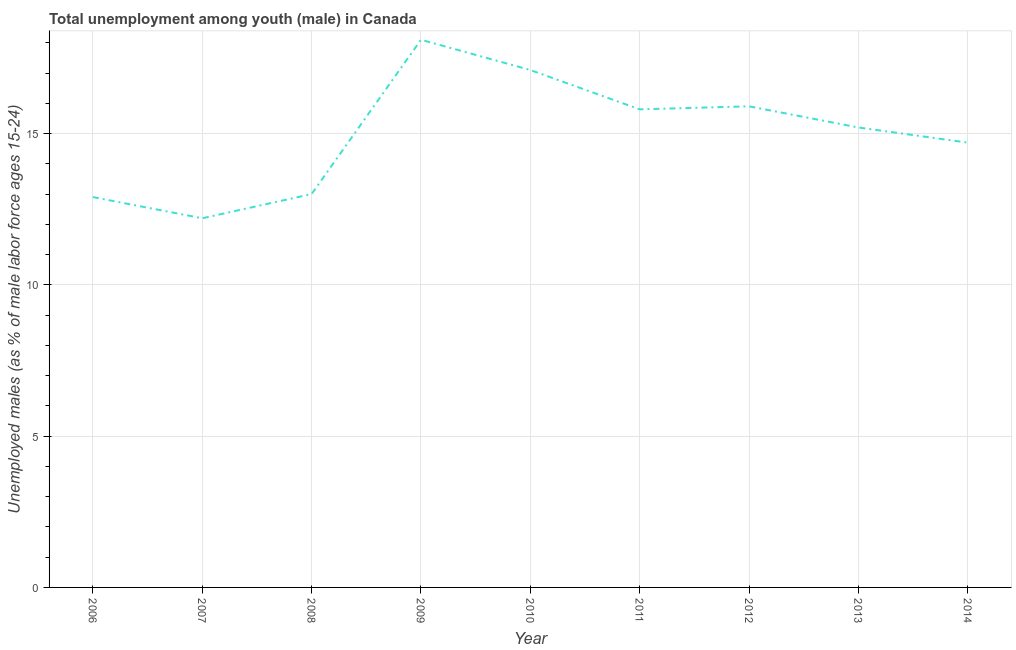What is the unemployed male youth population in 2009?
Keep it short and to the point. 18.1. Across all years, what is the maximum unemployed male youth population?
Provide a short and direct response. 18.1. Across all years, what is the minimum unemployed male youth population?
Give a very brief answer. 12.2. What is the sum of the unemployed male youth population?
Your answer should be compact. 134.9. What is the difference between the unemployed male youth population in 2010 and 2011?
Keep it short and to the point. 1.3. What is the average unemployed male youth population per year?
Your answer should be compact. 14.99. What is the median unemployed male youth population?
Give a very brief answer. 15.2. In how many years, is the unemployed male youth population greater than 12 %?
Offer a terse response. 9. What is the ratio of the unemployed male youth population in 2008 to that in 2010?
Give a very brief answer. 0.76. Is the unemployed male youth population in 2011 less than that in 2014?
Keep it short and to the point. No. Is the difference between the unemployed male youth population in 2011 and 2014 greater than the difference between any two years?
Offer a very short reply. No. What is the difference between the highest and the lowest unemployed male youth population?
Provide a succinct answer. 5.9. Does the unemployed male youth population monotonically increase over the years?
Provide a short and direct response. No. What is the difference between two consecutive major ticks on the Y-axis?
Provide a short and direct response. 5. What is the title of the graph?
Give a very brief answer. Total unemployment among youth (male) in Canada. What is the label or title of the Y-axis?
Make the answer very short. Unemployed males (as % of male labor force ages 15-24). What is the Unemployed males (as % of male labor force ages 15-24) in 2006?
Your response must be concise. 12.9. What is the Unemployed males (as % of male labor force ages 15-24) in 2007?
Your answer should be very brief. 12.2. What is the Unemployed males (as % of male labor force ages 15-24) of 2009?
Your answer should be compact. 18.1. What is the Unemployed males (as % of male labor force ages 15-24) of 2010?
Offer a very short reply. 17.1. What is the Unemployed males (as % of male labor force ages 15-24) in 2011?
Provide a succinct answer. 15.8. What is the Unemployed males (as % of male labor force ages 15-24) of 2012?
Offer a very short reply. 15.9. What is the Unemployed males (as % of male labor force ages 15-24) of 2013?
Your response must be concise. 15.2. What is the Unemployed males (as % of male labor force ages 15-24) of 2014?
Offer a terse response. 14.7. What is the difference between the Unemployed males (as % of male labor force ages 15-24) in 2006 and 2007?
Offer a very short reply. 0.7. What is the difference between the Unemployed males (as % of male labor force ages 15-24) in 2006 and 2009?
Offer a terse response. -5.2. What is the difference between the Unemployed males (as % of male labor force ages 15-24) in 2007 and 2010?
Give a very brief answer. -4.9. What is the difference between the Unemployed males (as % of male labor force ages 15-24) in 2007 and 2011?
Offer a terse response. -3.6. What is the difference between the Unemployed males (as % of male labor force ages 15-24) in 2007 and 2012?
Make the answer very short. -3.7. What is the difference between the Unemployed males (as % of male labor force ages 15-24) in 2008 and 2009?
Make the answer very short. -5.1. What is the difference between the Unemployed males (as % of male labor force ages 15-24) in 2008 and 2012?
Provide a succinct answer. -2.9. What is the difference between the Unemployed males (as % of male labor force ages 15-24) in 2008 and 2013?
Provide a succinct answer. -2.2. What is the difference between the Unemployed males (as % of male labor force ages 15-24) in 2009 and 2010?
Your answer should be compact. 1. What is the difference between the Unemployed males (as % of male labor force ages 15-24) in 2010 and 2014?
Your answer should be compact. 2.4. What is the difference between the Unemployed males (as % of male labor force ages 15-24) in 2011 and 2013?
Provide a short and direct response. 0.6. What is the difference between the Unemployed males (as % of male labor force ages 15-24) in 2012 and 2013?
Provide a succinct answer. 0.7. What is the ratio of the Unemployed males (as % of male labor force ages 15-24) in 2006 to that in 2007?
Offer a very short reply. 1.06. What is the ratio of the Unemployed males (as % of male labor force ages 15-24) in 2006 to that in 2008?
Ensure brevity in your answer.  0.99. What is the ratio of the Unemployed males (as % of male labor force ages 15-24) in 2006 to that in 2009?
Ensure brevity in your answer.  0.71. What is the ratio of the Unemployed males (as % of male labor force ages 15-24) in 2006 to that in 2010?
Keep it short and to the point. 0.75. What is the ratio of the Unemployed males (as % of male labor force ages 15-24) in 2006 to that in 2011?
Make the answer very short. 0.82. What is the ratio of the Unemployed males (as % of male labor force ages 15-24) in 2006 to that in 2012?
Offer a very short reply. 0.81. What is the ratio of the Unemployed males (as % of male labor force ages 15-24) in 2006 to that in 2013?
Give a very brief answer. 0.85. What is the ratio of the Unemployed males (as % of male labor force ages 15-24) in 2006 to that in 2014?
Your response must be concise. 0.88. What is the ratio of the Unemployed males (as % of male labor force ages 15-24) in 2007 to that in 2008?
Provide a short and direct response. 0.94. What is the ratio of the Unemployed males (as % of male labor force ages 15-24) in 2007 to that in 2009?
Your response must be concise. 0.67. What is the ratio of the Unemployed males (as % of male labor force ages 15-24) in 2007 to that in 2010?
Your response must be concise. 0.71. What is the ratio of the Unemployed males (as % of male labor force ages 15-24) in 2007 to that in 2011?
Give a very brief answer. 0.77. What is the ratio of the Unemployed males (as % of male labor force ages 15-24) in 2007 to that in 2012?
Ensure brevity in your answer.  0.77. What is the ratio of the Unemployed males (as % of male labor force ages 15-24) in 2007 to that in 2013?
Give a very brief answer. 0.8. What is the ratio of the Unemployed males (as % of male labor force ages 15-24) in 2007 to that in 2014?
Keep it short and to the point. 0.83. What is the ratio of the Unemployed males (as % of male labor force ages 15-24) in 2008 to that in 2009?
Offer a very short reply. 0.72. What is the ratio of the Unemployed males (as % of male labor force ages 15-24) in 2008 to that in 2010?
Your response must be concise. 0.76. What is the ratio of the Unemployed males (as % of male labor force ages 15-24) in 2008 to that in 2011?
Keep it short and to the point. 0.82. What is the ratio of the Unemployed males (as % of male labor force ages 15-24) in 2008 to that in 2012?
Your response must be concise. 0.82. What is the ratio of the Unemployed males (as % of male labor force ages 15-24) in 2008 to that in 2013?
Your answer should be very brief. 0.85. What is the ratio of the Unemployed males (as % of male labor force ages 15-24) in 2008 to that in 2014?
Offer a terse response. 0.88. What is the ratio of the Unemployed males (as % of male labor force ages 15-24) in 2009 to that in 2010?
Offer a very short reply. 1.06. What is the ratio of the Unemployed males (as % of male labor force ages 15-24) in 2009 to that in 2011?
Offer a terse response. 1.15. What is the ratio of the Unemployed males (as % of male labor force ages 15-24) in 2009 to that in 2012?
Offer a very short reply. 1.14. What is the ratio of the Unemployed males (as % of male labor force ages 15-24) in 2009 to that in 2013?
Your response must be concise. 1.19. What is the ratio of the Unemployed males (as % of male labor force ages 15-24) in 2009 to that in 2014?
Your answer should be compact. 1.23. What is the ratio of the Unemployed males (as % of male labor force ages 15-24) in 2010 to that in 2011?
Your answer should be very brief. 1.08. What is the ratio of the Unemployed males (as % of male labor force ages 15-24) in 2010 to that in 2012?
Offer a terse response. 1.07. What is the ratio of the Unemployed males (as % of male labor force ages 15-24) in 2010 to that in 2014?
Your answer should be compact. 1.16. What is the ratio of the Unemployed males (as % of male labor force ages 15-24) in 2011 to that in 2013?
Your response must be concise. 1.04. What is the ratio of the Unemployed males (as % of male labor force ages 15-24) in 2011 to that in 2014?
Provide a short and direct response. 1.07. What is the ratio of the Unemployed males (as % of male labor force ages 15-24) in 2012 to that in 2013?
Provide a short and direct response. 1.05. What is the ratio of the Unemployed males (as % of male labor force ages 15-24) in 2012 to that in 2014?
Your response must be concise. 1.08. What is the ratio of the Unemployed males (as % of male labor force ages 15-24) in 2013 to that in 2014?
Give a very brief answer. 1.03. 